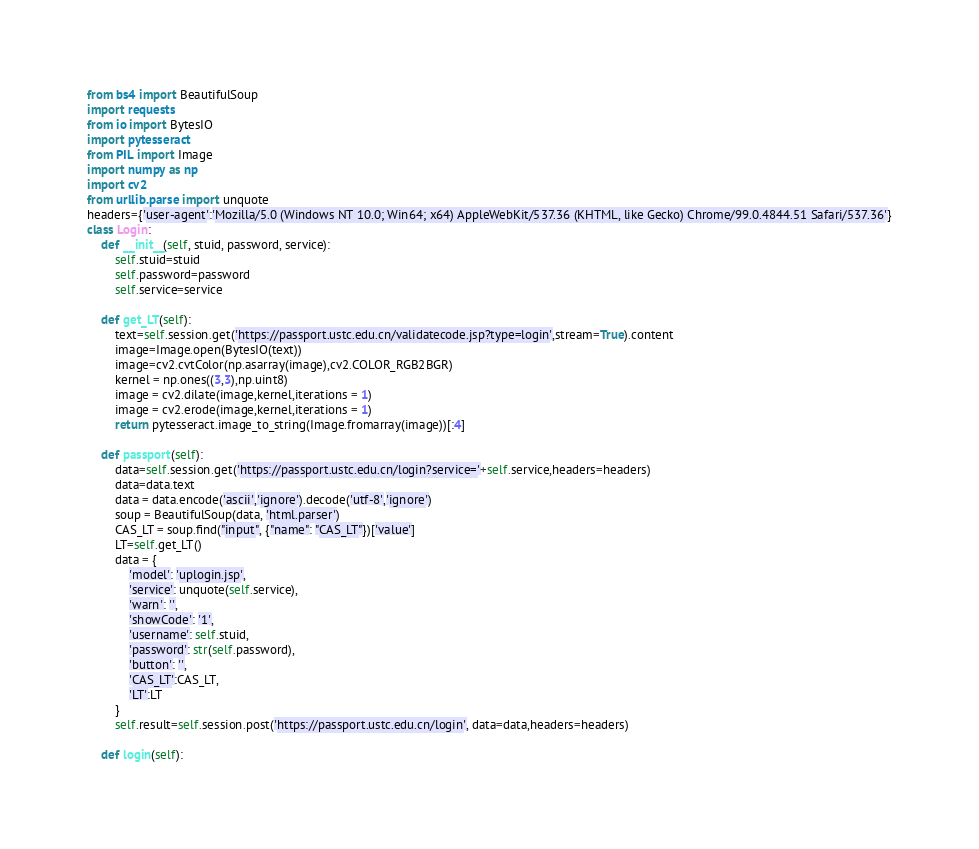<code> <loc_0><loc_0><loc_500><loc_500><_Python_>from bs4 import BeautifulSoup
import requests
from io import BytesIO
import pytesseract
from PIL import Image
import numpy as np
import cv2
from urllib.parse import unquote
headers={'user-agent':'Mozilla/5.0 (Windows NT 10.0; Win64; x64) AppleWebKit/537.36 (KHTML, like Gecko) Chrome/99.0.4844.51 Safari/537.36'}
class Login:
    def __init__(self, stuid, password, service):
        self.stuid=stuid
        self.password=password
        self.service=service
        
    def get_LT(self):
        text=self.session.get('https://passport.ustc.edu.cn/validatecode.jsp?type=login',stream=True).content
        image=Image.open(BytesIO(text))
        image=cv2.cvtColor(np.asarray(image),cv2.COLOR_RGB2BGR)
        kernel = np.ones((3,3),np.uint8)
        image = cv2.dilate(image,kernel,iterations = 1)
        image = cv2.erode(image,kernel,iterations = 1)
        return pytesseract.image_to_string(Image.fromarray(image))[:4]
    
    def passport(self):
        data=self.session.get('https://passport.ustc.edu.cn/login?service='+self.service,headers=headers)
        data=data.text
        data = data.encode('ascii','ignore').decode('utf-8','ignore')
        soup = BeautifulSoup(data, 'html.parser')
        CAS_LT = soup.find("input", {"name": "CAS_LT"})['value']
        LT=self.get_LT()
        data = {
            'model': 'uplogin.jsp',
            'service': unquote(self.service),
            'warn': '',
            'showCode': '1',
            'username': self.stuid,
            'password': str(self.password),
            'button': '',
            'CAS_LT':CAS_LT,
            'LT':LT
        }
        self.result=self.session.post('https://passport.ustc.edu.cn/login', data=data,headers=headers)
        
    def login(self):</code> 